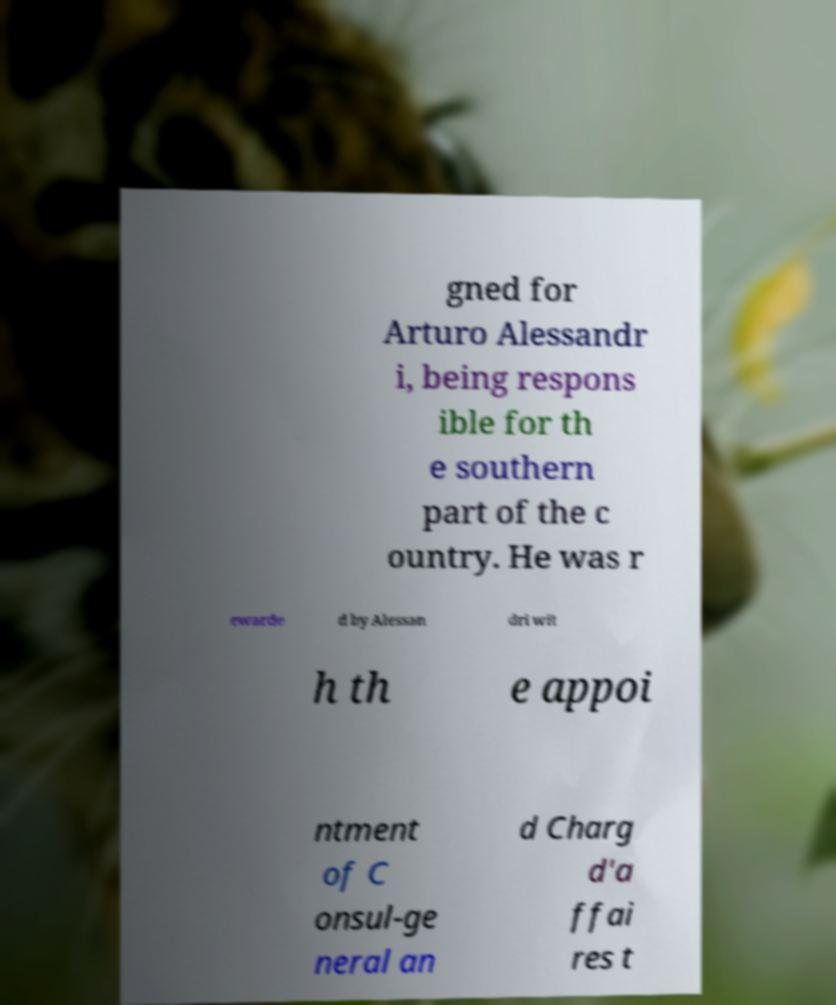Could you extract and type out the text from this image? gned for Arturo Alessandr i, being respons ible for th e southern part of the c ountry. He was r ewarde d by Alessan dri wit h th e appoi ntment of C onsul-ge neral an d Charg d'a ffai res t 